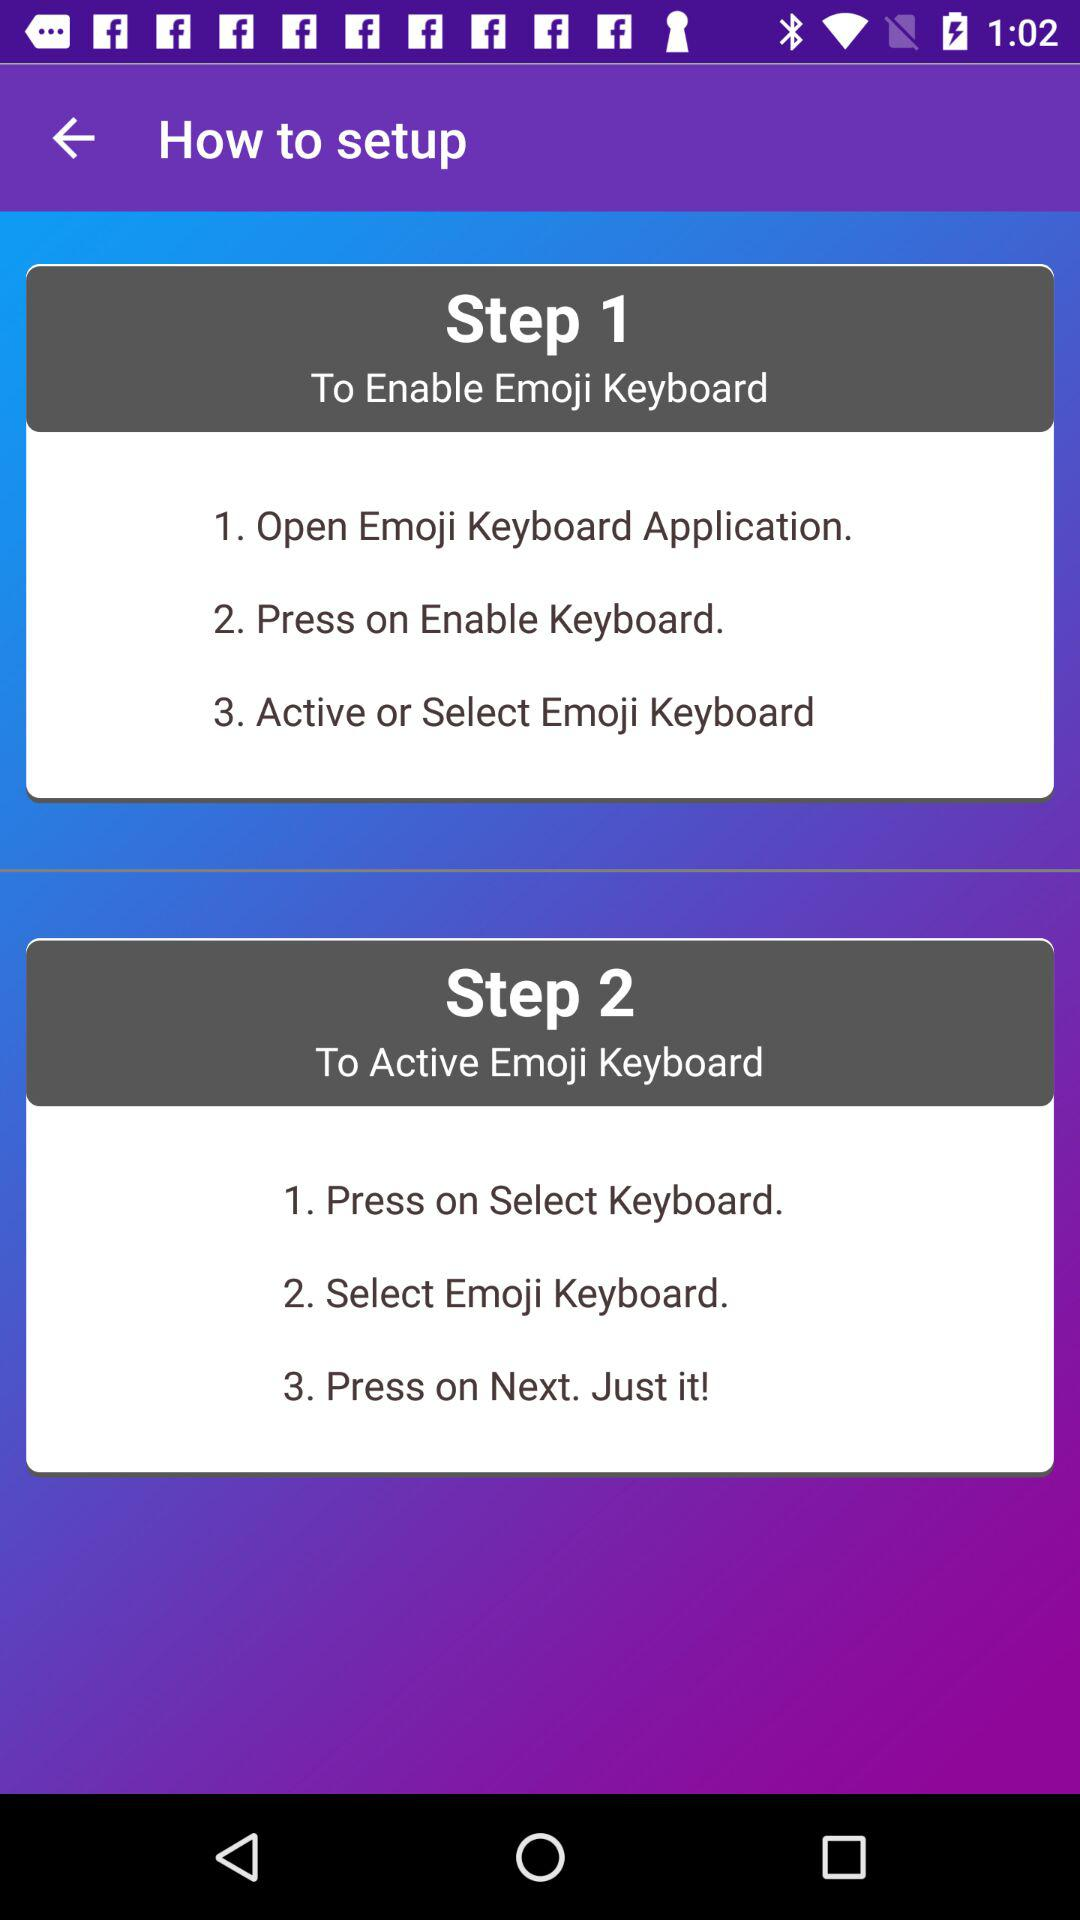What does Step 1 include? Step 1 includes "Open Emoji Keyboard Application", "Press on Enable Keyboard" and "Active or Select Emoji Keyboard". 